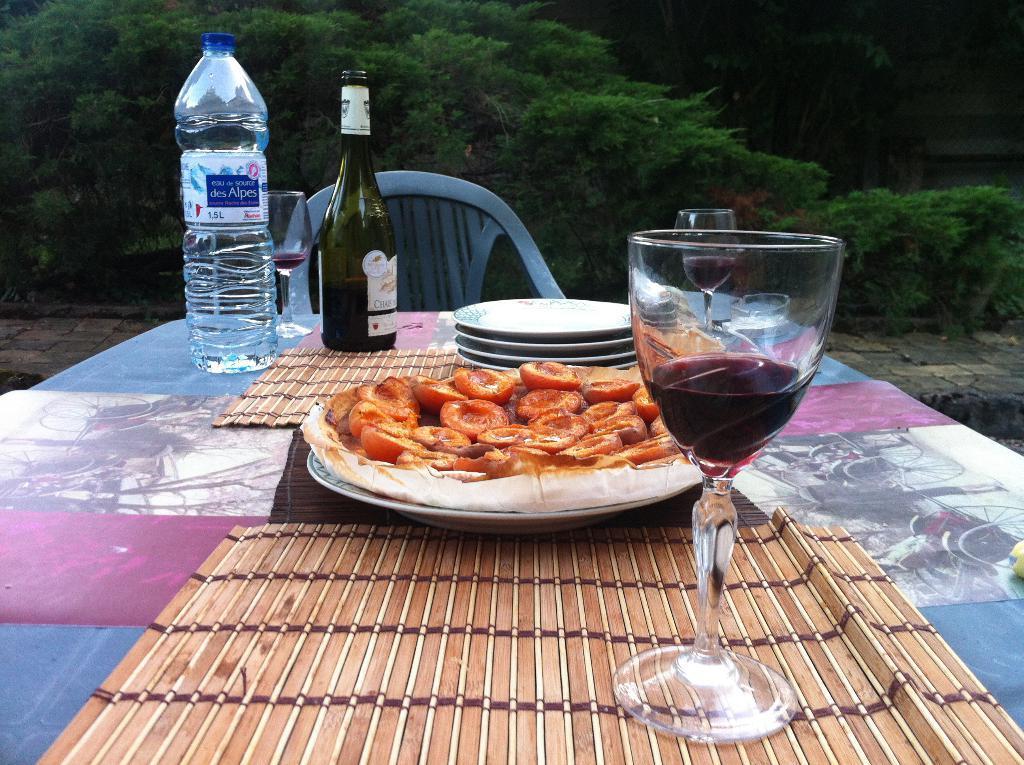Can you describe this image briefly? There is a food on table with alcohol bottle and water bottle and wine in glass. 